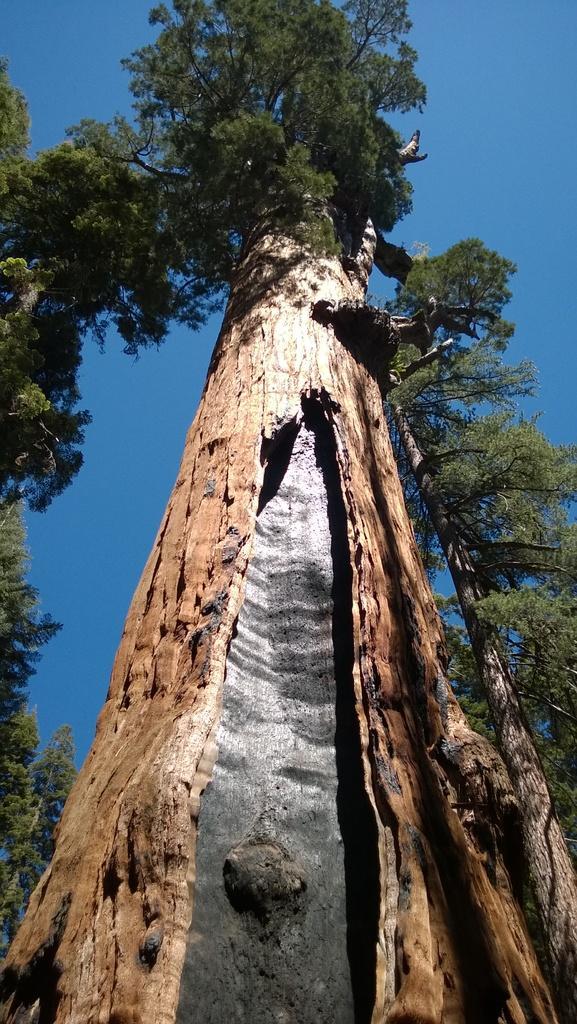Can you describe this image briefly? In the center of the image there is a tree. Image also consists of trees in the left and in the right. Sky is also visible. 